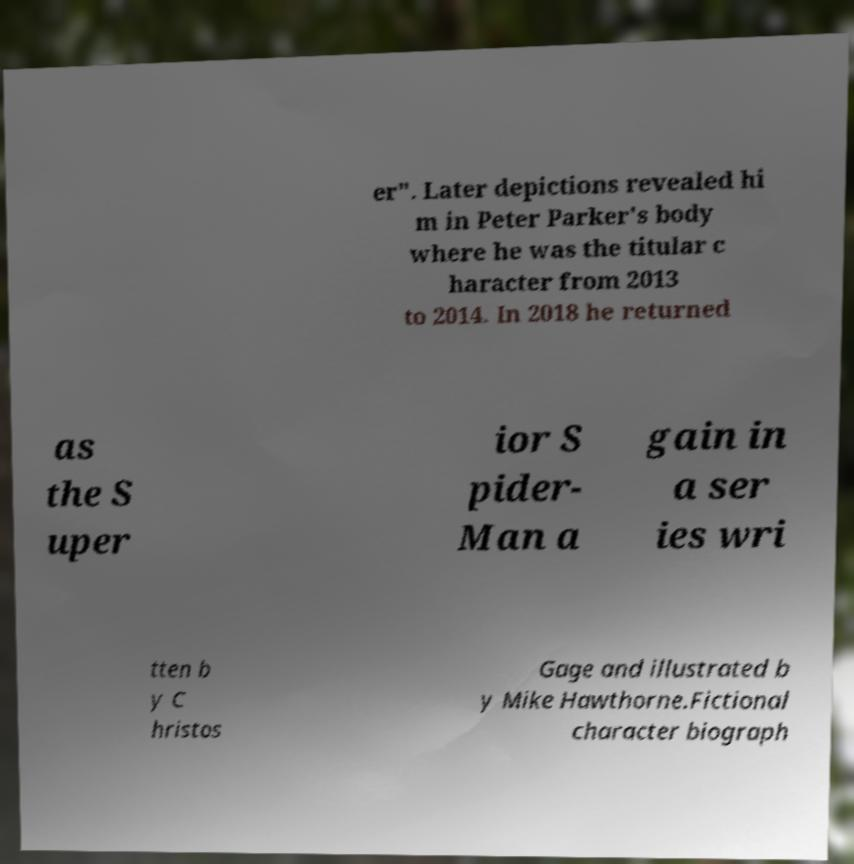Could you extract and type out the text from this image? er". Later depictions revealed hi m in Peter Parker's body where he was the titular c haracter from 2013 to 2014. In 2018 he returned as the S uper ior S pider- Man a gain in a ser ies wri tten b y C hristos Gage and illustrated b y Mike Hawthorne.Fictional character biograph 